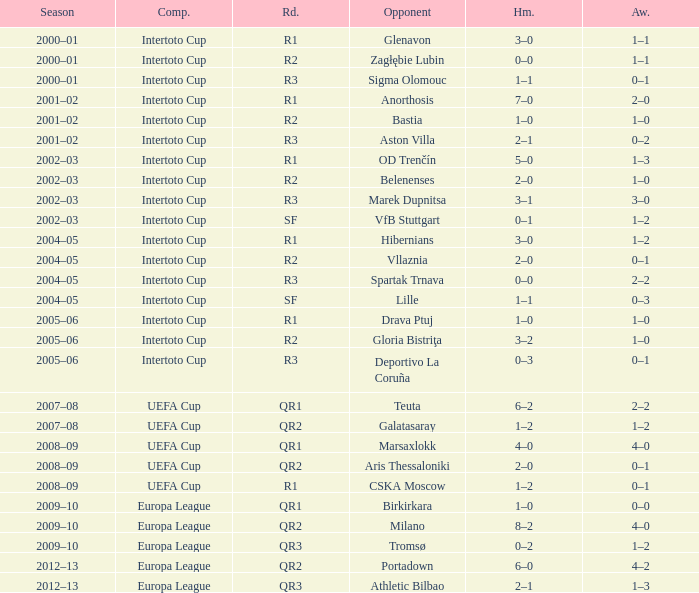What is the home score with marek dupnitsa as opponent? 3–1. 